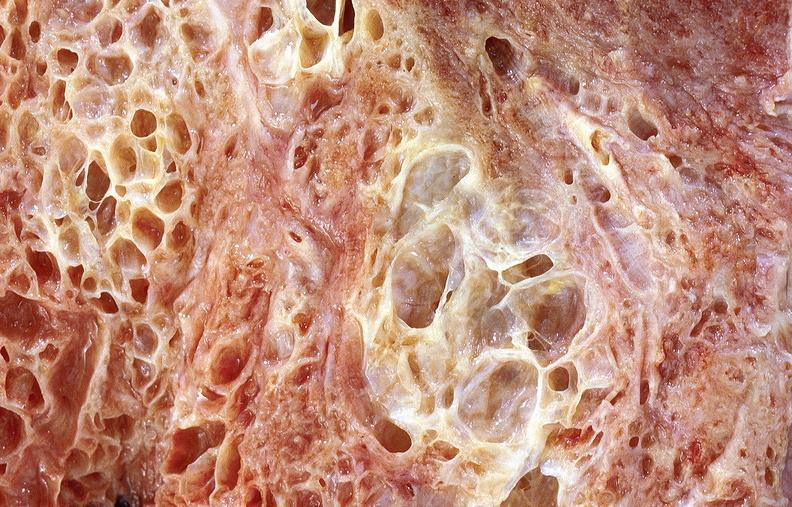what is present?
Answer the question using a single word or phrase. Respiratory 